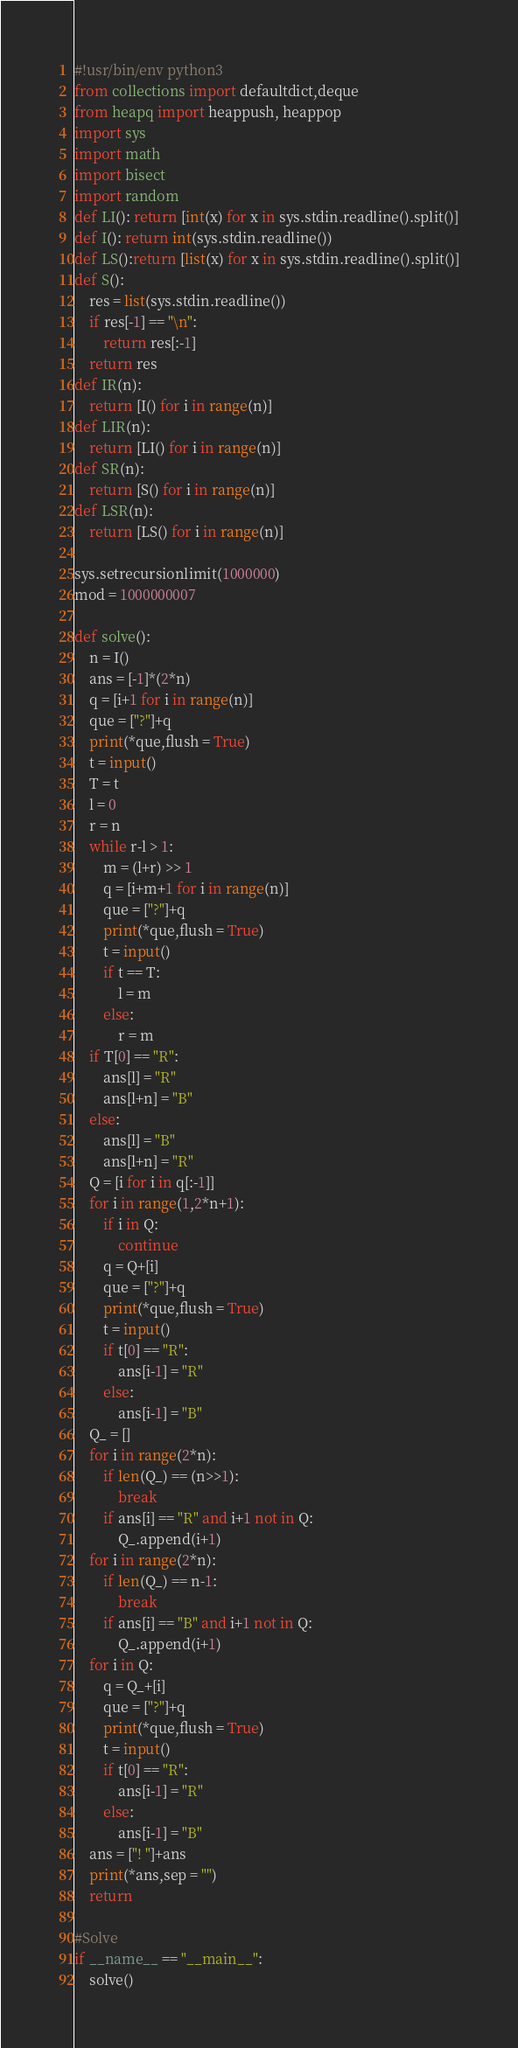Convert code to text. <code><loc_0><loc_0><loc_500><loc_500><_Python_>#!usr/bin/env python3
from collections import defaultdict,deque
from heapq import heappush, heappop
import sys
import math
import bisect
import random
def LI(): return [int(x) for x in sys.stdin.readline().split()]
def I(): return int(sys.stdin.readline())
def LS():return [list(x) for x in sys.stdin.readline().split()]
def S():
    res = list(sys.stdin.readline())
    if res[-1] == "\n":
        return res[:-1]
    return res
def IR(n):
    return [I() for i in range(n)]
def LIR(n):
    return [LI() for i in range(n)]
def SR(n):
    return [S() for i in range(n)]
def LSR(n):
    return [LS() for i in range(n)]

sys.setrecursionlimit(1000000)
mod = 1000000007

def solve():
    n = I()
    ans = [-1]*(2*n)
    q = [i+1 for i in range(n)]
    que = ["?"]+q
    print(*que,flush = True)
    t = input()
    T = t
    l = 0
    r = n
    while r-l > 1:
        m = (l+r) >> 1
        q = [i+m+1 for i in range(n)]
        que = ["?"]+q
        print(*que,flush = True)
        t = input()
        if t == T:
            l = m
        else:
            r = m
    if T[0] == "R":
        ans[l] = "R"
        ans[l+n] = "B"
    else:
        ans[l] = "B"
        ans[l+n] = "R"
    Q = [i for i in q[:-1]]
    for i in range(1,2*n+1):
        if i in Q:
            continue
        q = Q+[i]
        que = ["?"]+q
        print(*que,flush = True)
        t = input()
        if t[0] == "R":
            ans[i-1] = "R"
        else:
            ans[i-1] = "B"
    Q_ = []
    for i in range(2*n):
        if len(Q_) == (n>>1):
            break
        if ans[i] == "R" and i+1 not in Q:
            Q_.append(i+1)
    for i in range(2*n):
        if len(Q_) == n-1:
            break
        if ans[i] == "B" and i+1 not in Q:
            Q_.append(i+1)
    for i in Q:
        q = Q_+[i]
        que = ["?"]+q
        print(*que,flush = True)
        t = input()
        if t[0] == "R":
            ans[i-1] = "R"
        else:
            ans[i-1] = "B"
    ans = ["! "]+ans
    print(*ans,sep = "")
    return

#Solve
if __name__ == "__main__":
    solve()
</code> 